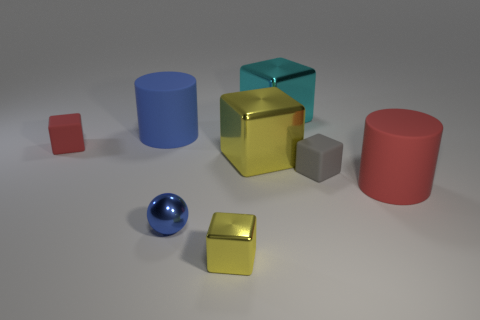Subtract all big yellow shiny blocks. How many blocks are left? 4 Add 2 large cyan metallic things. How many objects exist? 10 Subtract all yellow blocks. How many blocks are left? 3 Subtract all cubes. How many objects are left? 3 Subtract 1 cylinders. How many cylinders are left? 1 Subtract all cyan cylinders. Subtract all purple cubes. How many cylinders are left? 2 Subtract all red spheres. How many brown cylinders are left? 0 Subtract all large red matte cylinders. Subtract all small gray cubes. How many objects are left? 6 Add 5 balls. How many balls are left? 6 Add 8 big red cylinders. How many big red cylinders exist? 9 